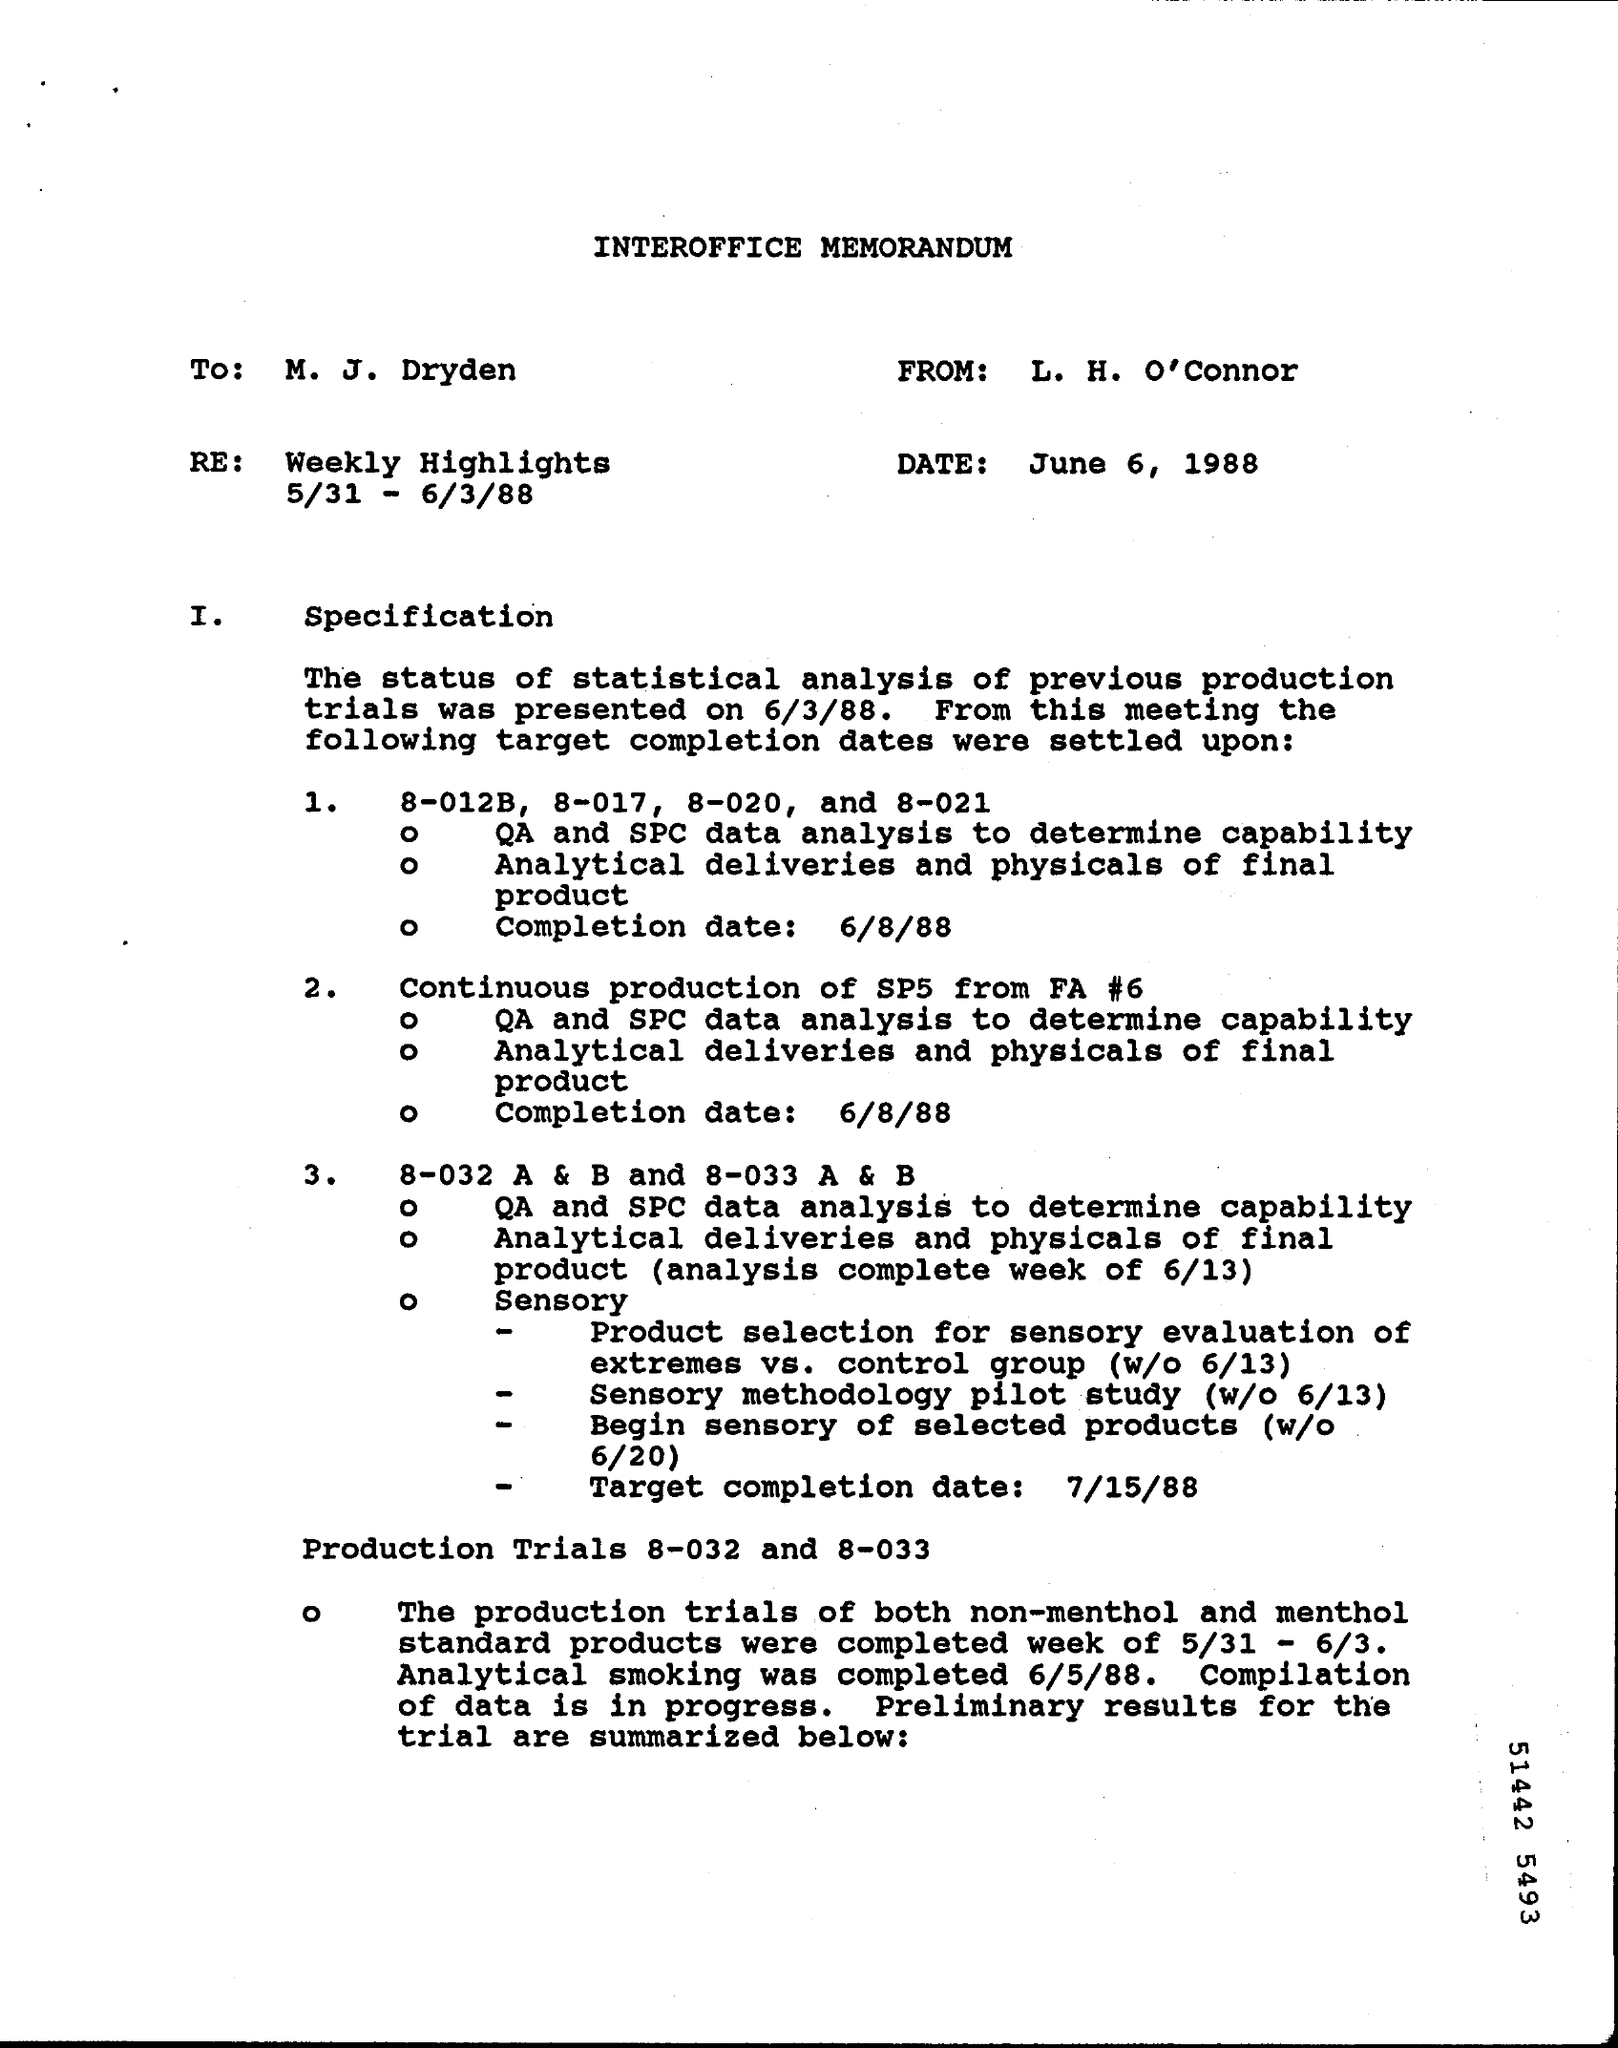Point out several critical features in this image. The memorandum is from L. H. O'Connor. On June 6, 1988, the date is known. 